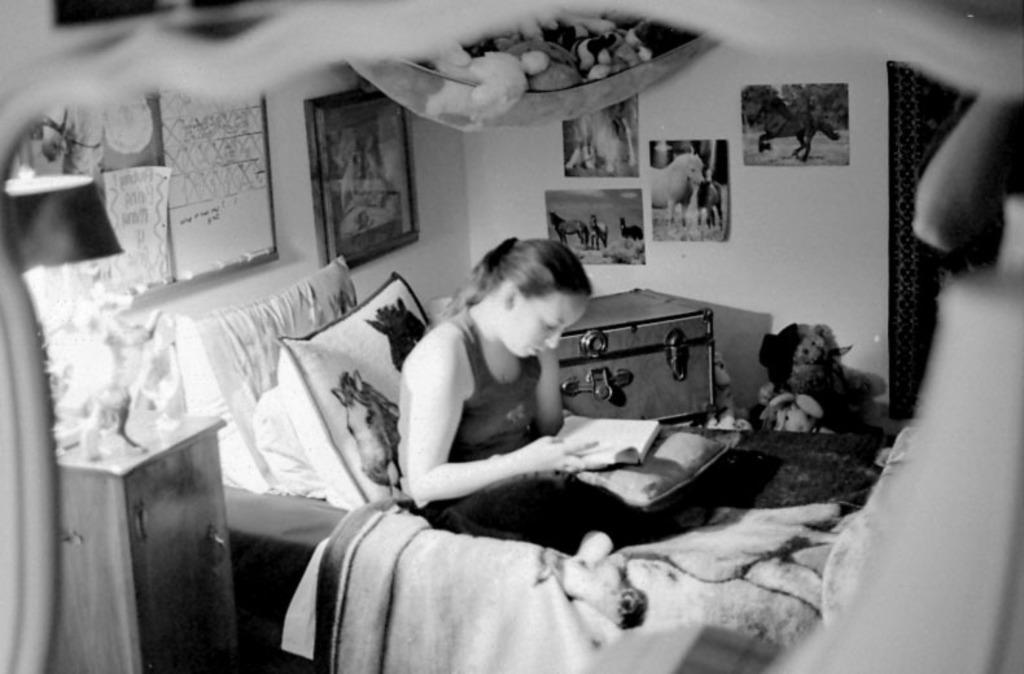In one or two sentences, can you explain what this image depicts? This is a picture taken inside view of a room and a woman sit on the bed there are the pillows kept on the bed and there are the photo frames attached to the wall there is a left side there is a table and there is a lamp and on the left side she is studying a book and there are the some teddy bears on the right side. 